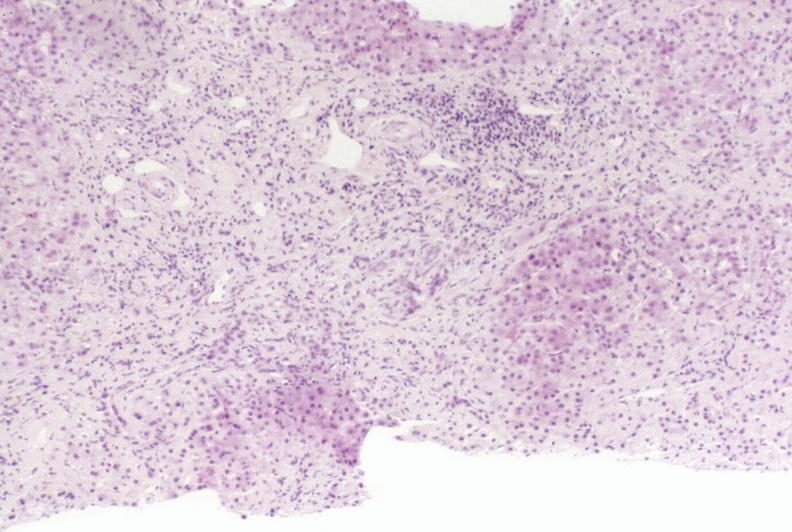s liver present?
Answer the question using a single word or phrase. Yes 